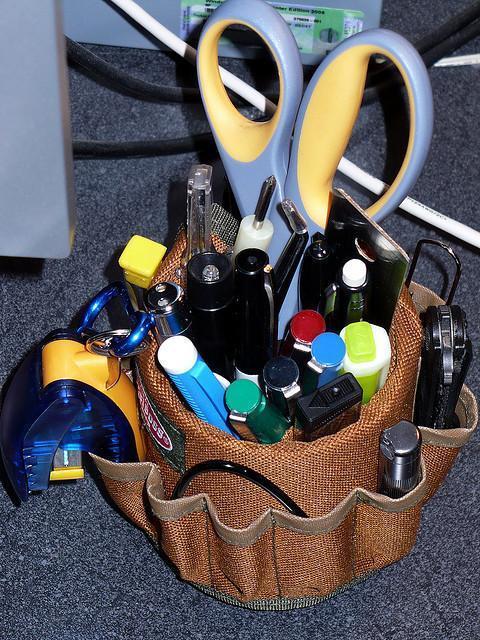How many pairs of scissors are visible in this photo?
Give a very brief answer. 1. How many people are holding elephant's nose?
Give a very brief answer. 0. 